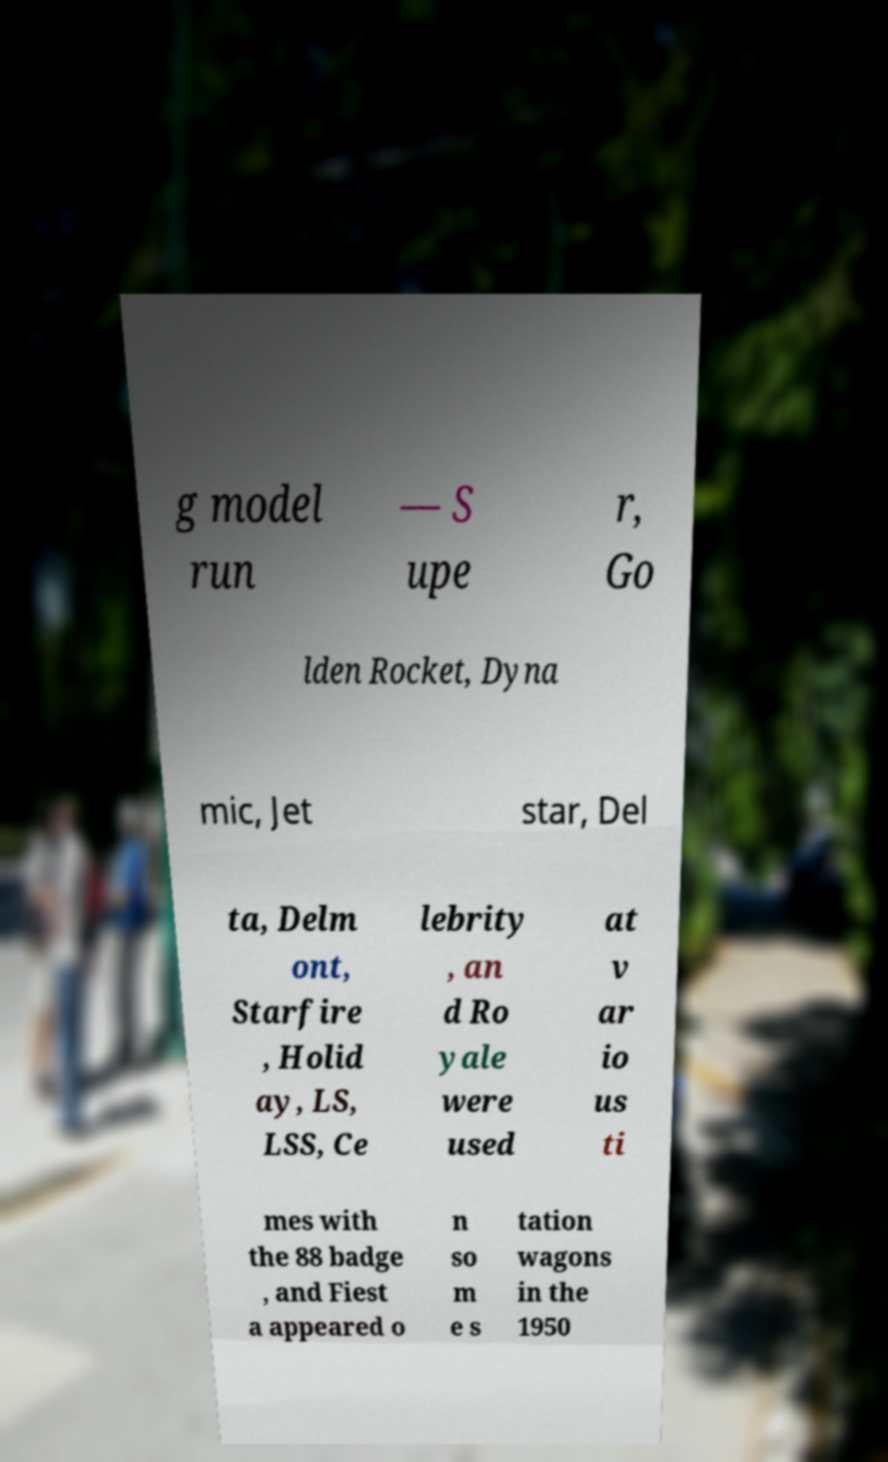I need the written content from this picture converted into text. Can you do that? g model run — S upe r, Go lden Rocket, Dyna mic, Jet star, Del ta, Delm ont, Starfire , Holid ay, LS, LSS, Ce lebrity , an d Ro yale were used at v ar io us ti mes with the 88 badge , and Fiest a appeared o n so m e s tation wagons in the 1950 